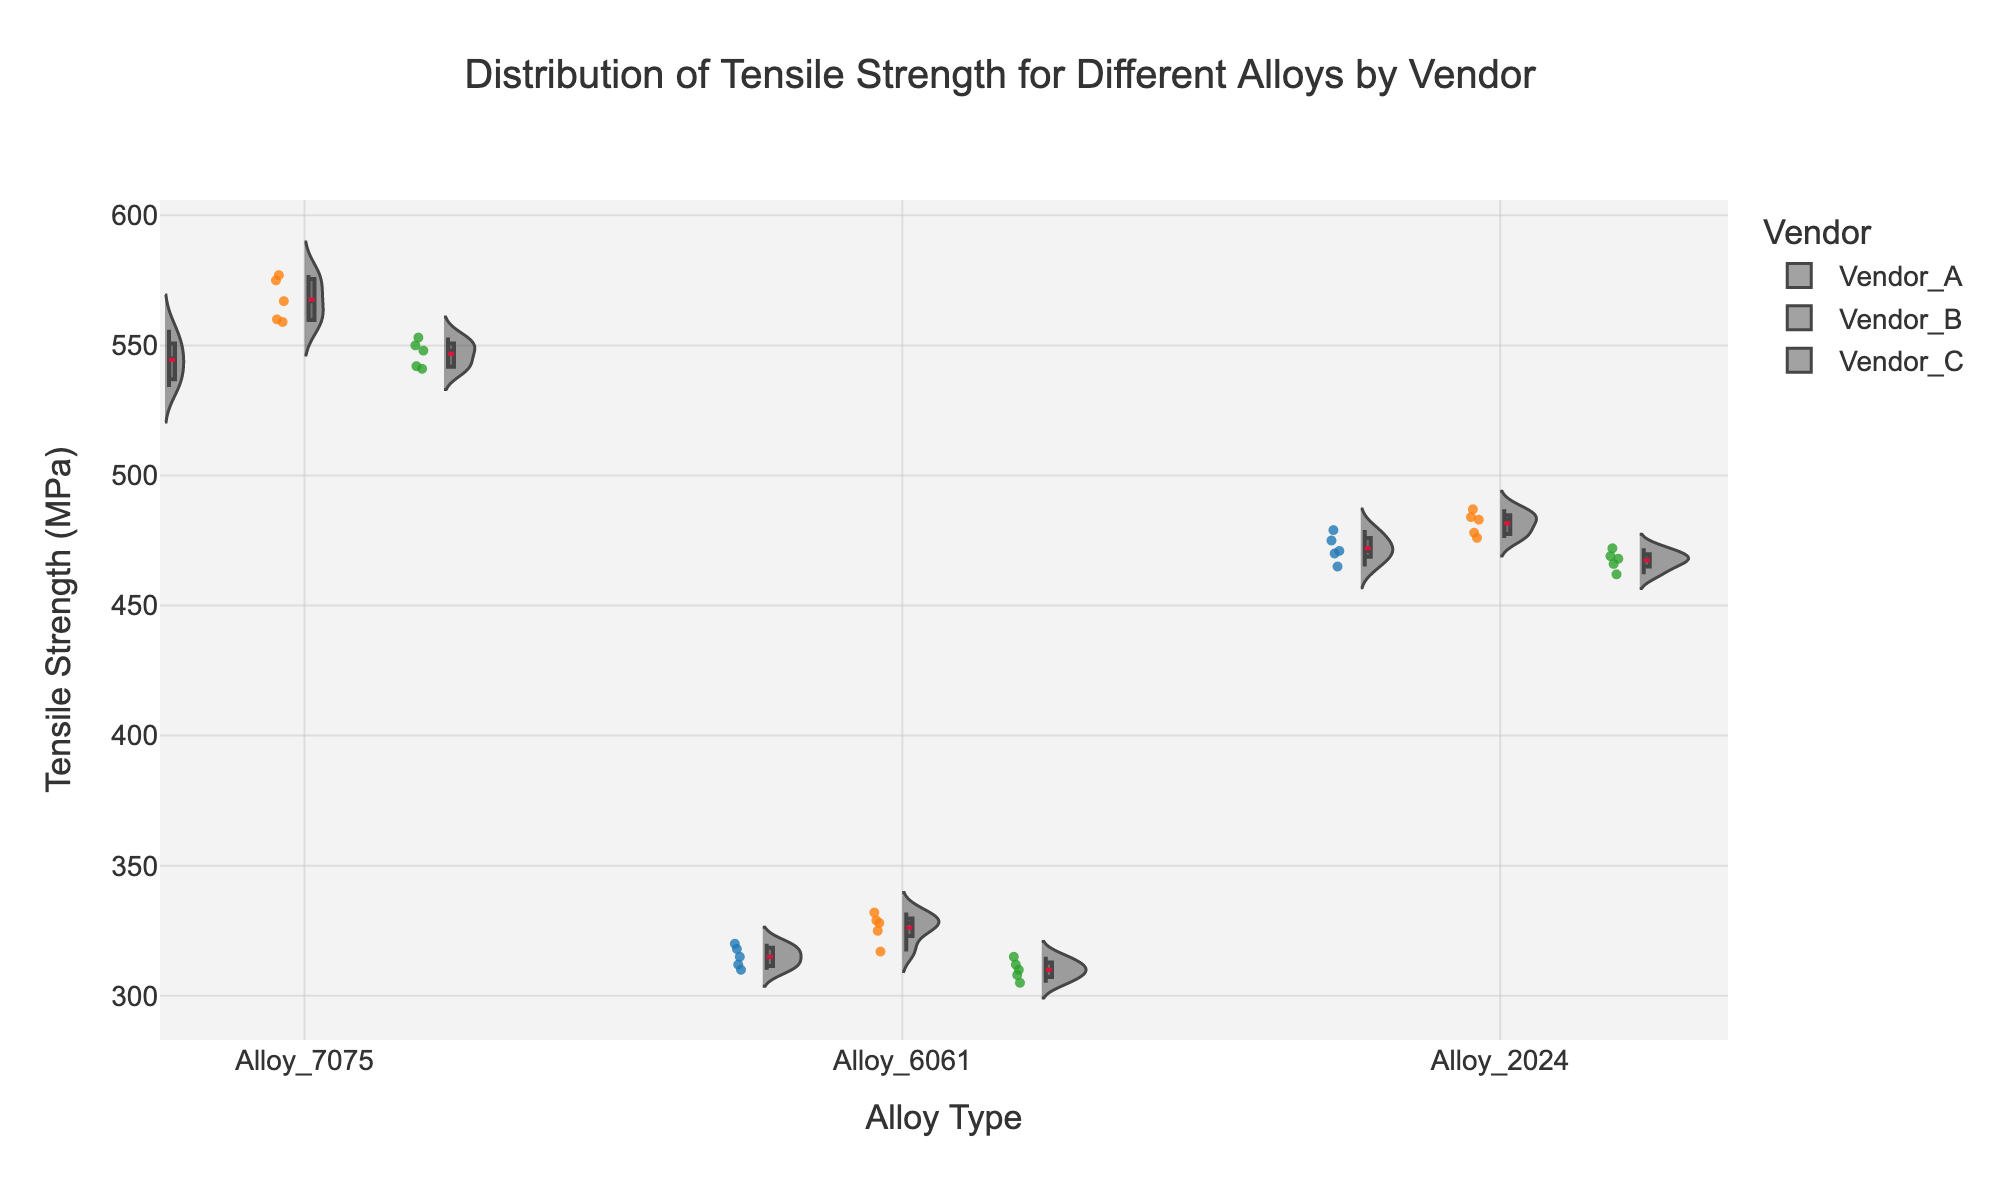What are the main colors used to differentiate the vendors in the plot? The colors used to differentiate the vendors are blue for Vendor A, orange for Vendor B, and green for Vendor C.
Answer: blue, orange, green What is the range of tensile strength values for Alloy 7075 from Vendor B? The range is determined by identifying the minimum and maximum values of the tensile strength for Vendor B and Alloy 7075. From the data, Vendor B's Alloy 7075 has tensile strength values between 559 MPa and 577 MPa.
Answer: 559 to 577 MPa Which vendor shows the highest median tensile strength for Alloy 2024? By examining the box plots within the violin plot, find the median line within the boxes for Alloy 2024. Vendor B's median line is the highest for Alloy 2024.
Answer: Vendor B Do any of the alloys exhibit a bimodal distribution for tensile strength for any vendor? A bimodal distribution will show two peaks within the violin plot. Upon examining the violin plots, no alloy distribution shows a clear bimodal pattern, indicating typically one peak per vendor for each alloy.
Answer: No How do the tensile strength ranges for Alloy 6061 compare between the vendors? Compare the minimum and maximum values in the box plots for each vendor. Vendor A ranges from 310 to 320 MPa, Vendor B from 317 to 332 MPa, and Vendor C from 305 to 315 MPa. Vendor B has the highest range, followed by Vendor A, then Vendor C.
Answer: Vendor B > Vendor A > Vendor C What is the interquartile range (IQR) of tensile strength values for Alloy 2024 from Vendor A? The interquartile range (IQR) is calculated by subtracting the first quartile (Q1) from the third quartile (Q3). For Vendor A's Alloy 2024, Q3 is 475 MPa and Q1 is 465 MPa, so the IQR is 475 - 465 = 10 MPa.
Answer: 10 MPa Which alloy shows the most variability in tensile strength for Vendor C? Determine the most variability by looking at the width of the violin plots and the length of the box plots. For Vendor C, Alloy 7075 has the widest spread, indicating the most variability.
Answer: Alloy 7075 What is the average tensile strength of Alloy 6061 for Vendor C? Sum the tensile strength values for Alloy 6061 from Vendor C and divide by the number of data points. (305 + 310 + 312 + 308 + 315)/5 = 310 MPa.
Answer: 310 MPa Is there any overlap in tensile strength values among the different alloys for Vendor A? Examine the box plots and ranges for overlaps. Alloys 7075 and 2024 overlap significantly, with Alloy 6061 having lower tensile strength values without overlapping the others.
Answer: Yes, between Alloy 7075 and Alloy 2024 How do the median tensile strength values for Alloy 7075 compare across all vendors? Identify the median lines in the box plots for Alloy 7075. Medians are Vendor A: 545 MPa, Vendor B: 567 MPa, Vendor C: 548 MPa. Vendor B has the highest, followed by Vendor C, then Vendor A.
Answer: Vendor B > Vendor C > Vendor A 